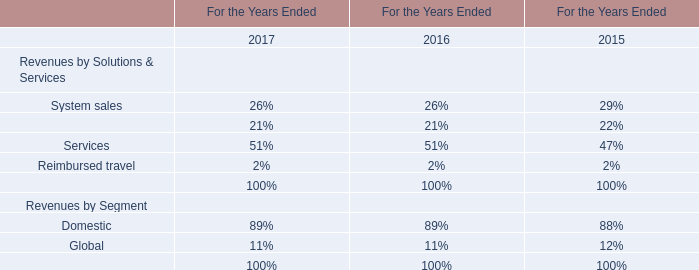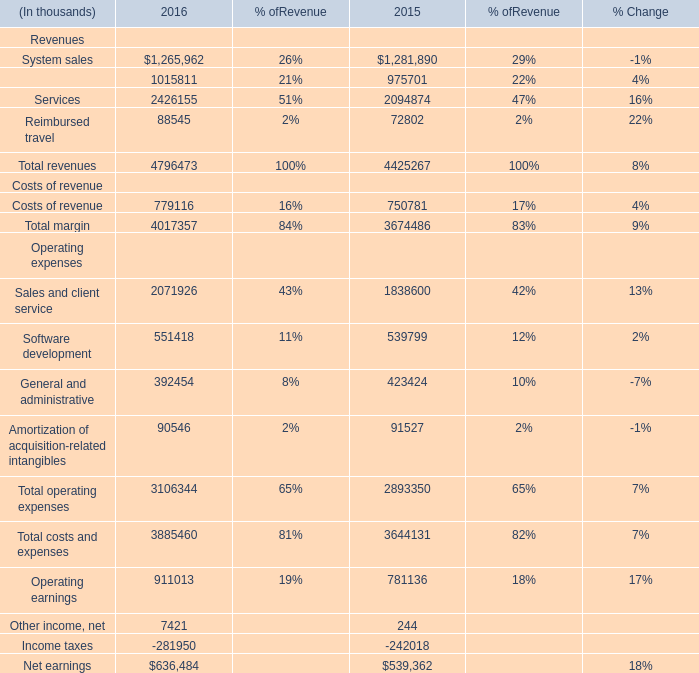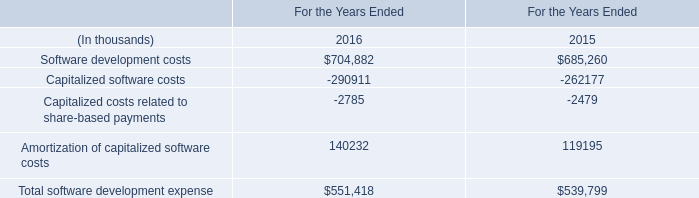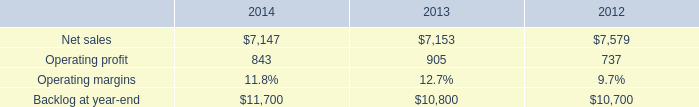What will Reimbursed travel Revenue reach in 2017 if it continues to grow at its current rate? (in thousand) 
Computations: ((1 + ((88545 - 72802) / 72802)) * 88545)
Answer: 107692.33022. 